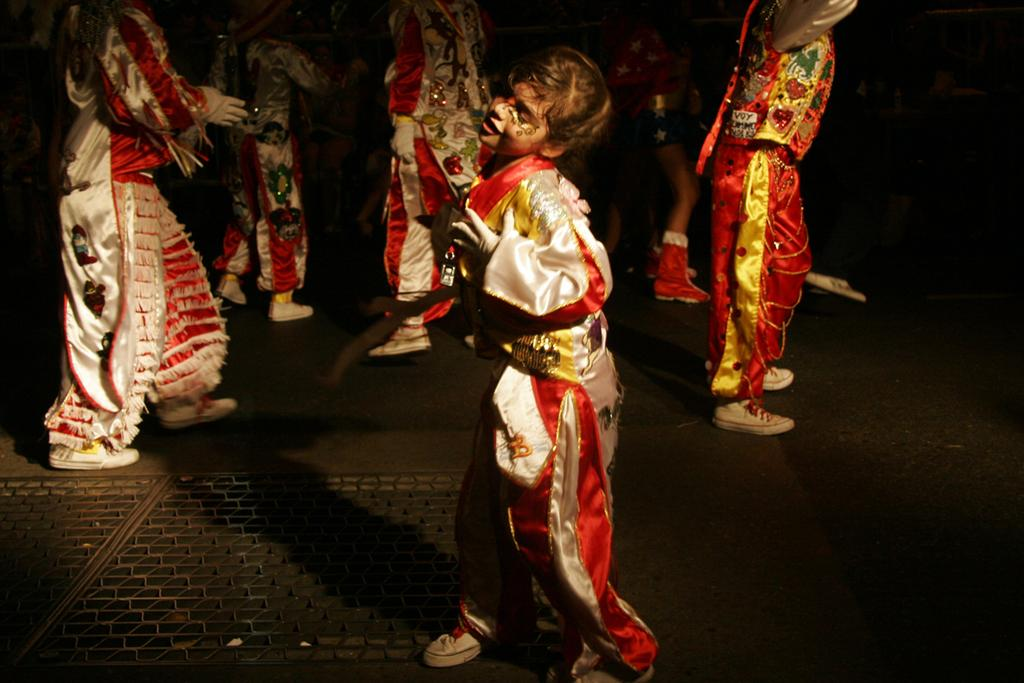Who or what is present in the image? There are people in the image. What are the people doing in the image? The people are dancing on the floor. What colors are the costumes of the people in the image? The people are wearing white and red color costumes. What can be observed about the background of the image? The background of the image is dark. Can you see a lake in the background of the image? No, there is no lake present in the image. Is there a net visible in the image? No, there is no net visible in the image. 